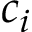<formula> <loc_0><loc_0><loc_500><loc_500>c _ { i }</formula> 